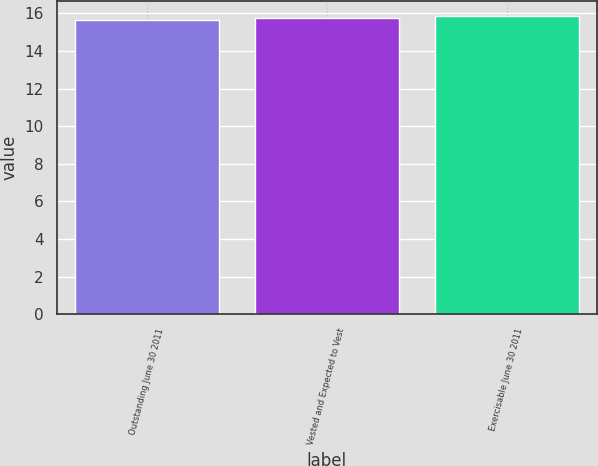Convert chart. <chart><loc_0><loc_0><loc_500><loc_500><bar_chart><fcel>Outstanding June 30 2011<fcel>Vested and Expected to Vest<fcel>Exercisable June 30 2011<nl><fcel>15.65<fcel>15.75<fcel>15.85<nl></chart> 